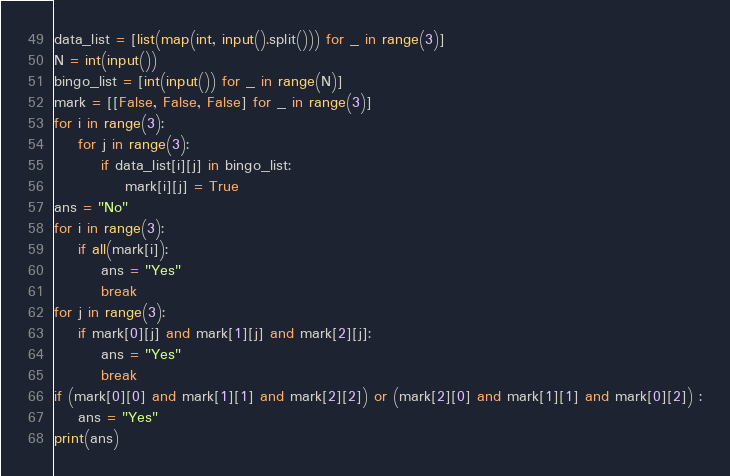<code> <loc_0><loc_0><loc_500><loc_500><_Python_>data_list = [list(map(int, input().split())) for _ in range(3)]
N = int(input())
bingo_list = [int(input()) for _ in range(N)]
mark = [[False, False, False] for _ in range(3)]
for i in range(3):
    for j in range(3):
        if data_list[i][j] in bingo_list:
            mark[i][j] = True
ans = "No"
for i in range(3):
    if all(mark[i]):
        ans = "Yes"
        break
for j in range(3):
    if mark[0][j] and mark[1][j] and mark[2][j]:
        ans = "Yes"
        break
if (mark[0][0] and mark[1][1] and mark[2][2]) or (mark[2][0] and mark[1][1] and mark[0][2]) :
    ans = "Yes"
print(ans)
</code> 